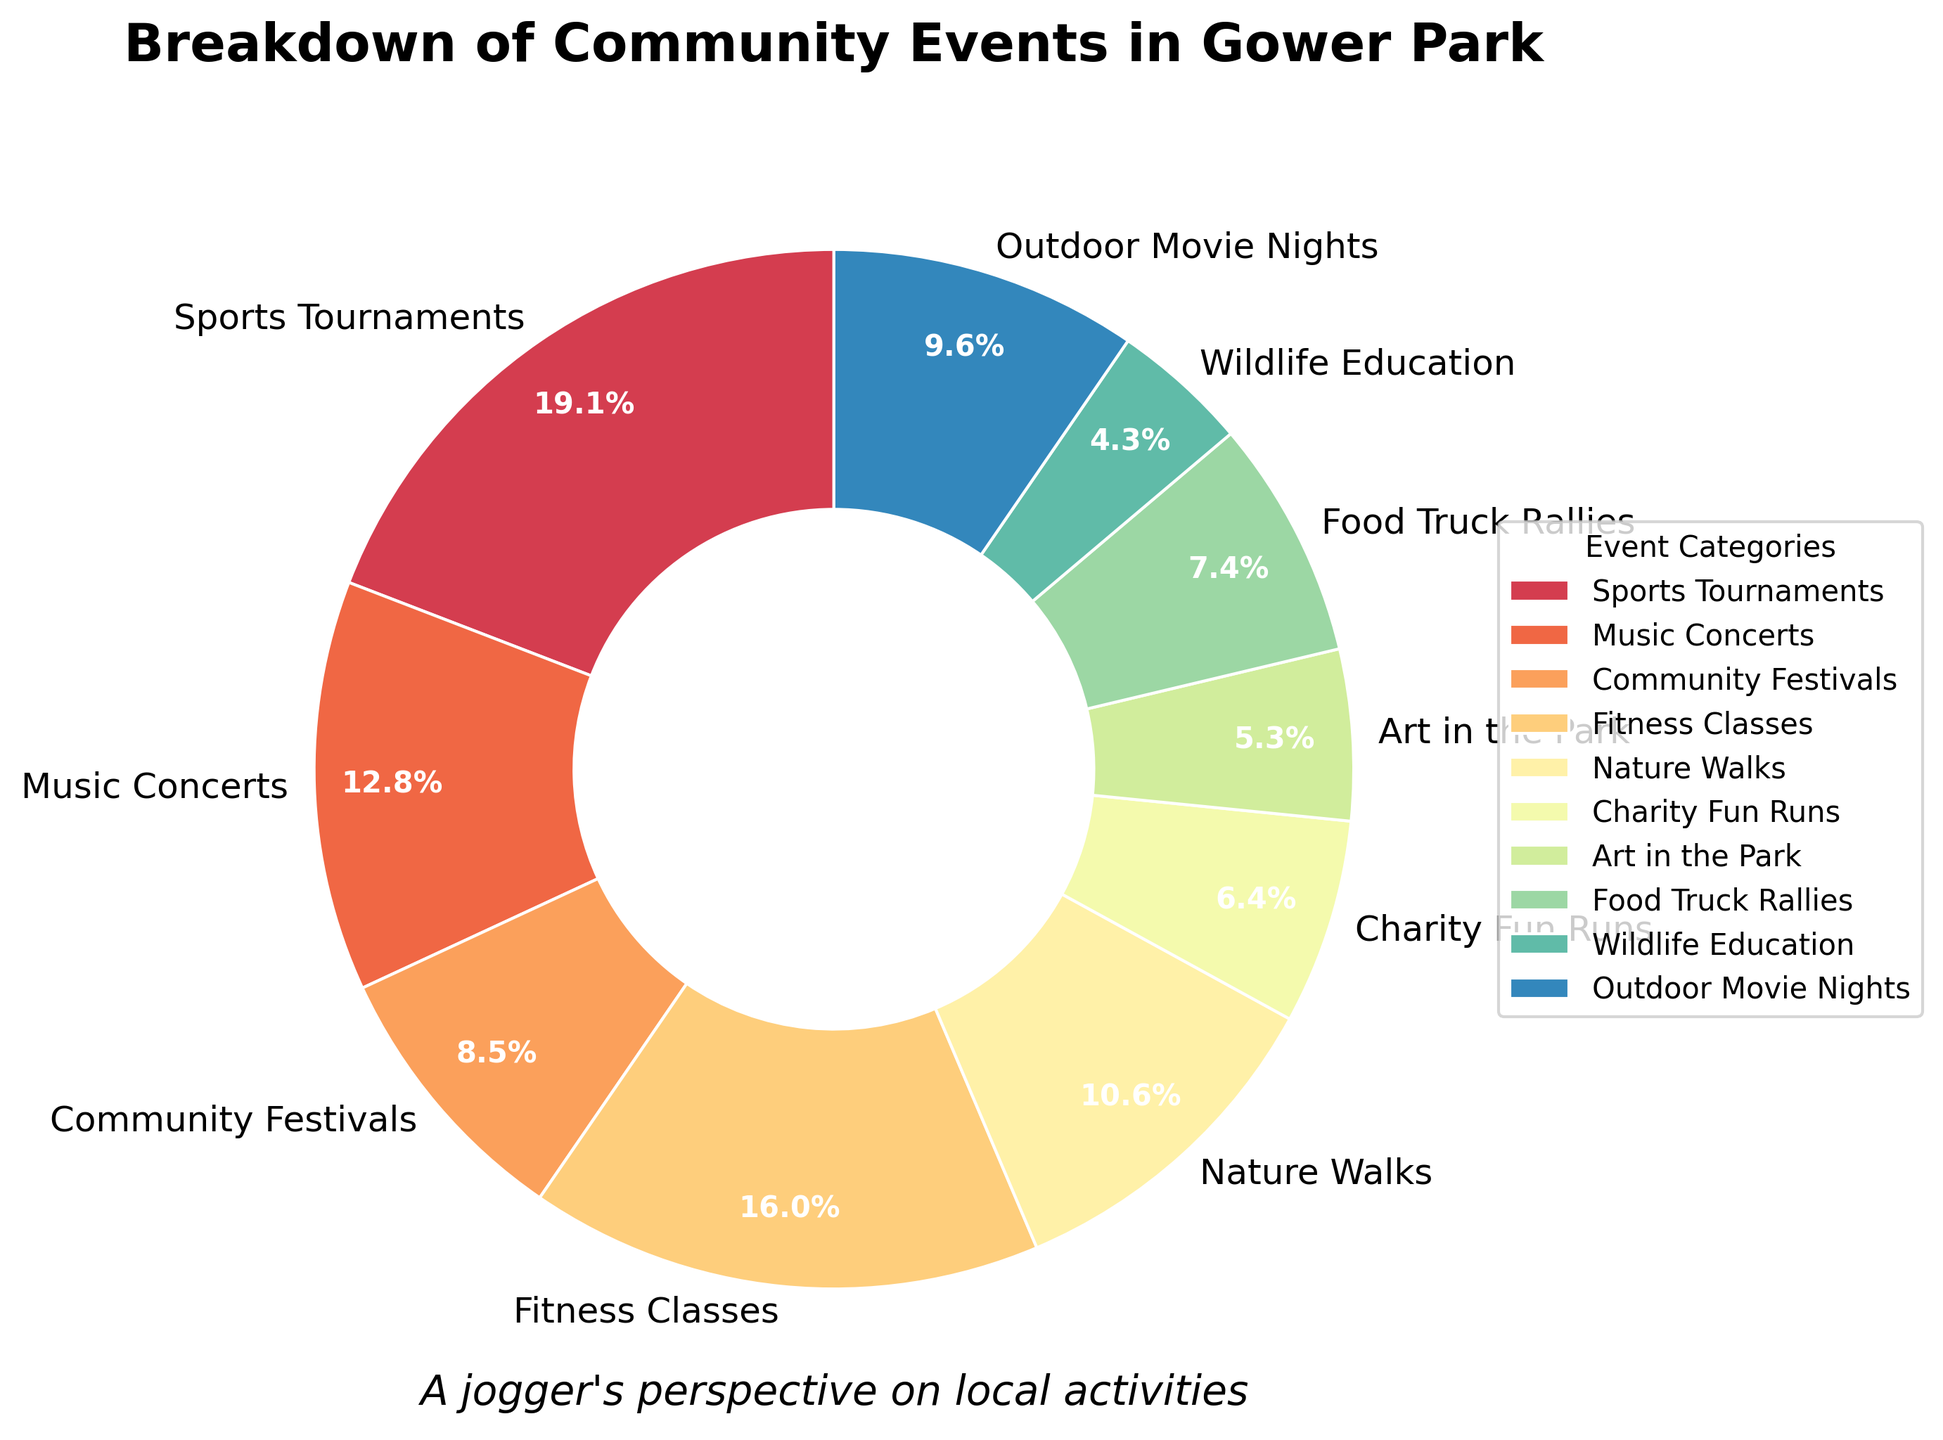How many event categories are there in total? There are 10 different slices in the pie chart, each representing a different category of events.
Answer: 10 Which event category has the smallest slice in the pie chart? The slice for "Wildlife Education" is the smallest in the pie chart.
Answer: Wildlife Education What percentage of events are sports tournaments? The slice for "Sports Tournaments" shows 18%, as indicated by the pie chart's label.
Answer: 18% Does "Fitness Classes" have a larger or smaller share compared to "Music Concerts"? The slice for "Fitness Classes" (15%) is larger than the slice for "Music Concerts" (12%), as indicated by the pie chart's labels.
Answer: Larger What is the combined percentage for "Nature Walks" and "Outdoor Movie Nights"? "Nature Walks" has 10% and "Outdoor Movie Nights" has 9%. The combined percentage is 10% + 9% = 19%.
Answer: 19% What is the total number of events for categories that have more than 7 events each? Categories with more than 7 events are: Sports Tournaments (18), Music Concerts (12), Fitness Classes (15), Nature Walks (10), and Outdoor Movie Nights (9). Total = 18 + 12 + 15 + 10 + 9 = 64.
Answer: 64 Which categories have a share of less than 5% in the pie chart? The slices for "Charity Fun Runs" (6 events, 6/94 ≈ 6.4%), "Art in the Park" (5 events, 5/94 ≈ 5.3%), and "Wildlife Education" (4 events, 4/94 ≈ 4.3%) are less than 5% each. Note: only "Wildlife Education" is actually below 5%.
Answer: Wildlife Education How does "Food Truck Rallies" compare visually to "Community Festivals"? The slice for "Food Truck Rallies" (7%) is smaller than the slice for "Community Festivals" (8%), as indicated by pie chart sizes.
Answer: Smaller What is the difference in the number of events between "Sports Tournaments" and "Food Truck Rallies"? Sports Tournaments (18 events) - Food Truck Rallies (7 events) = 18 - 7 = 11 events.
Answer: 11 